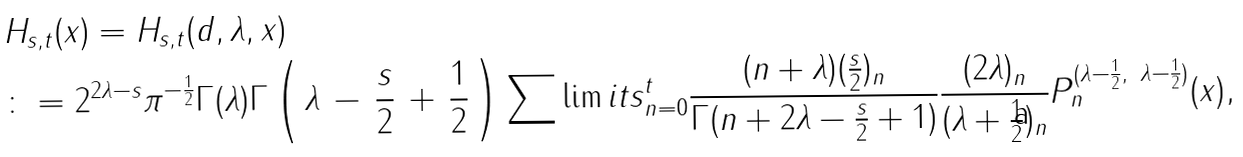<formula> <loc_0><loc_0><loc_500><loc_500>& H _ { s , t } ( x ) = H _ { s , t } ( d , \lambda , x ) \\ & \colon = 2 ^ { 2 \lambda - s } \pi ^ { - \frac { 1 } { 2 } } \Gamma ( \lambda ) \Gamma \left ( \, \lambda \, - \, \frac { s } { 2 } \, + \, \frac { 1 } { 2 } \, \right ) \sum \lim i t s _ { n = 0 } ^ { t } \frac { ( n + \lambda ) ( \frac { s } { 2 } ) _ { n } } { \Gamma ( n + 2 \lambda - \frac { s } { 2 } + 1 ) } \frac { ( 2 \lambda ) _ { n } } { ( \lambda + \frac { 1 } { 2 } ) _ { n } } P _ { n } ^ { ( \lambda - \frac { 1 } { 2 } , \ \lambda - \frac { 1 } { 2 } ) } ( x ) ,</formula> 